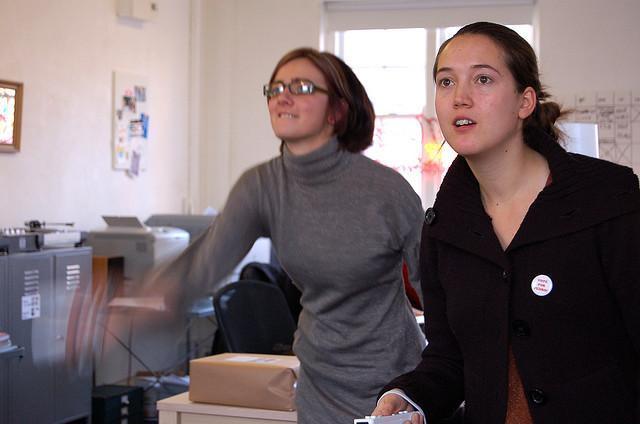How many chairs are there?
Give a very brief answer. 1. How many people are there?
Give a very brief answer. 2. How many kites are flying?
Give a very brief answer. 0. 